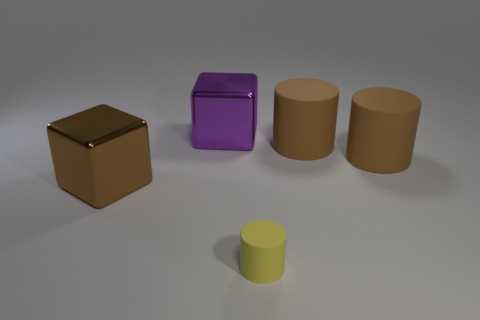Is the material of the block left of the purple block the same as the large purple object?
Make the answer very short. Yes. Is the number of big brown cylinders that are behind the purple metal thing less than the number of purple blocks?
Offer a very short reply. Yes. The other cube that is the same size as the brown metal cube is what color?
Offer a very short reply. Purple. What number of large brown matte things have the same shape as the purple object?
Make the answer very short. 0. The metallic cube that is to the right of the brown block is what color?
Provide a short and direct response. Purple. How many metal objects are either large cylinders or big purple blocks?
Provide a short and direct response. 1. What number of yellow rubber objects are the same size as the purple metal object?
Give a very brief answer. 0. What color is the large object that is both behind the large brown metal block and left of the yellow matte object?
Keep it short and to the point. Purple. How many objects are red shiny objects or matte objects?
Give a very brief answer. 3. What number of tiny things are either brown cylinders or purple cylinders?
Your answer should be very brief. 0. 